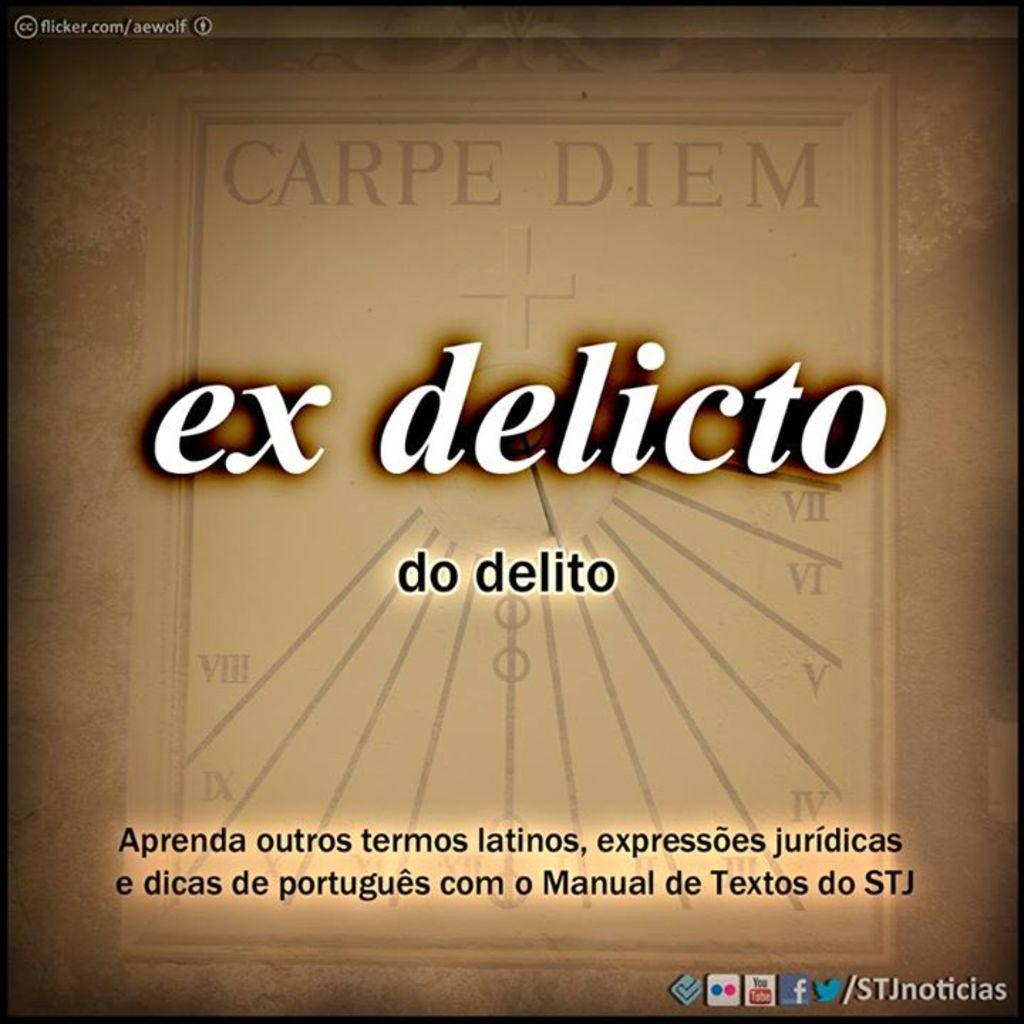<image>
Provide a brief description of the given image. Ex Delicto written on a tan background with lined designs. 